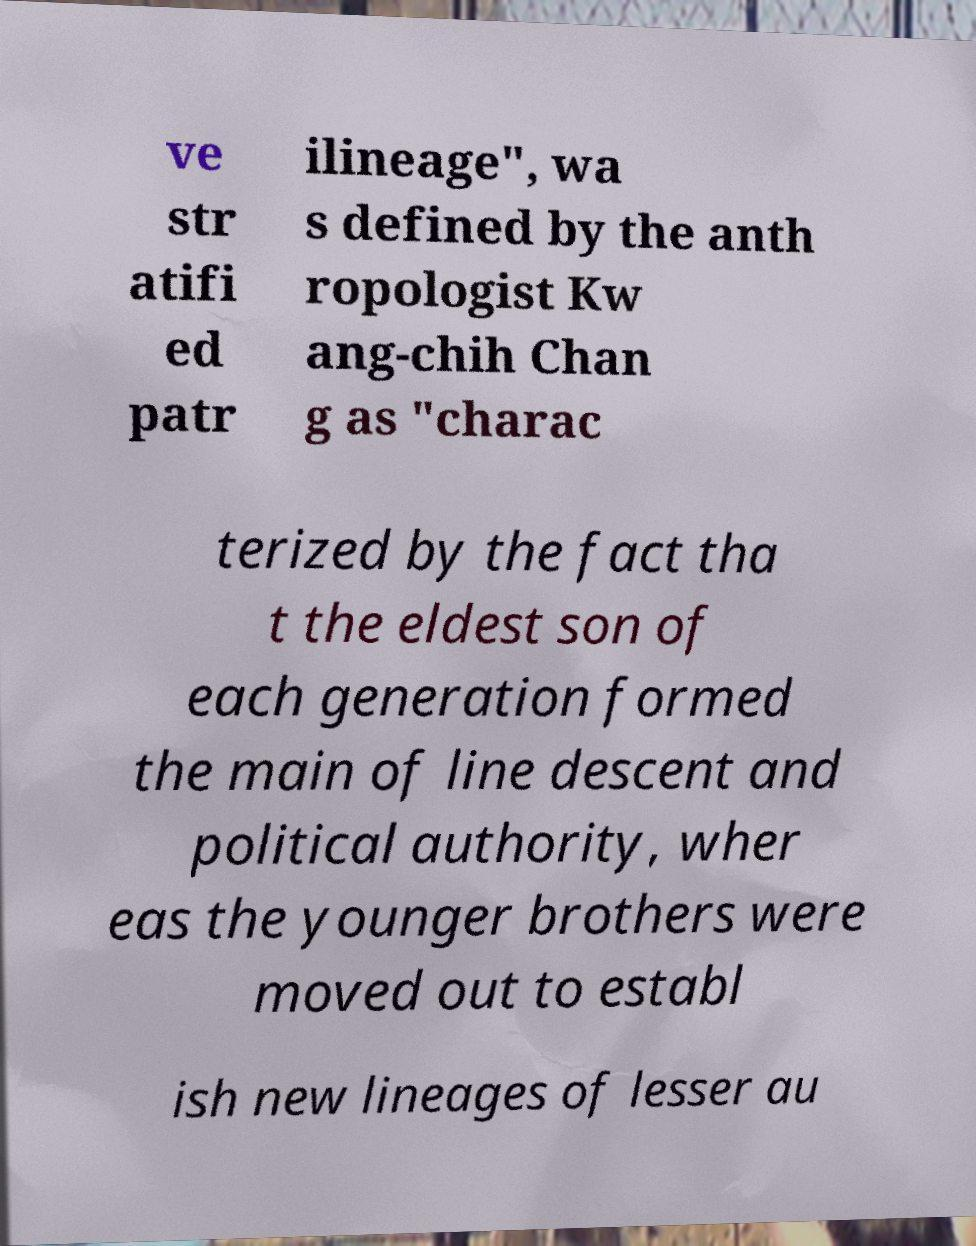Could you extract and type out the text from this image? ve str atifi ed patr ilineage", wa s defined by the anth ropologist Kw ang-chih Chan g as "charac terized by the fact tha t the eldest son of each generation formed the main of line descent and political authority, wher eas the younger brothers were moved out to establ ish new lineages of lesser au 